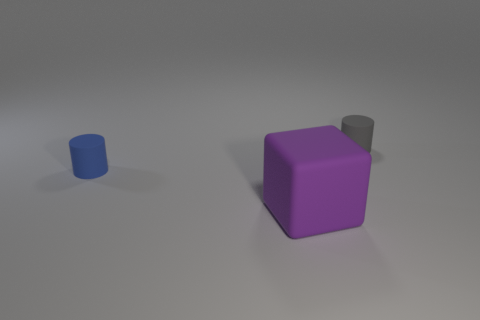Is the number of matte cylinders less than the number of objects?
Offer a terse response. Yes. There is a rubber object that is both behind the purple rubber thing and to the right of the blue rubber cylinder; what size is it?
Provide a short and direct response. Small. There is a cylinder that is behind the matte cylinder that is in front of the tiny cylinder that is right of the purple object; how big is it?
Give a very brief answer. Small. How many objects are blue matte cylinders or big brown spheres?
Keep it short and to the point. 1. What color is the small cylinder behind the blue cylinder?
Offer a terse response. Gray. Are there fewer large rubber cubes left of the purple rubber object than large purple rubber cubes?
Provide a short and direct response. Yes. Are there any other things that are the same size as the purple object?
Your answer should be compact. No. Are the block and the tiny gray cylinder made of the same material?
Your answer should be very brief. Yes. How many objects are matte cylinders that are behind the small blue matte cylinder or rubber objects right of the tiny blue rubber thing?
Make the answer very short. 2. Are there any purple cubes that have the same size as the blue matte cylinder?
Your answer should be very brief. No. 